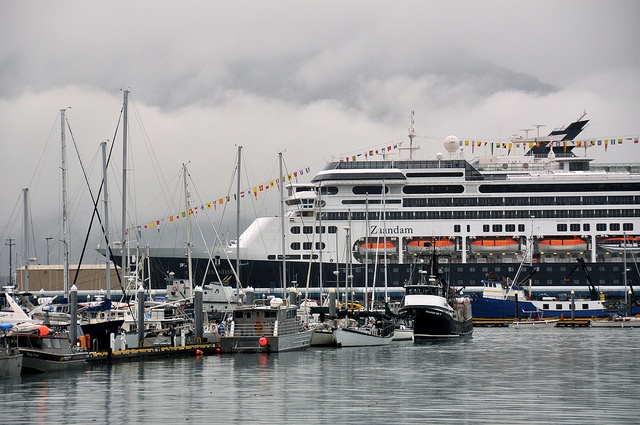Describe the objects in this image and their specific colors. I can see boat in darkgray, black, lightgray, and gray tones, boat in darkgray, black, gray, and lightgray tones, boat in darkgray, black, gray, and lightgray tones, boat in darkgray, black, gray, and lightgray tones, and boat in darkgray, gray, black, and lightgray tones in this image. 